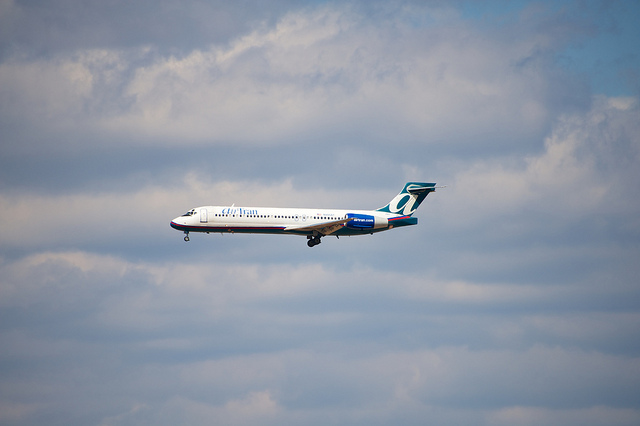Please transcribe the text in this image. a 